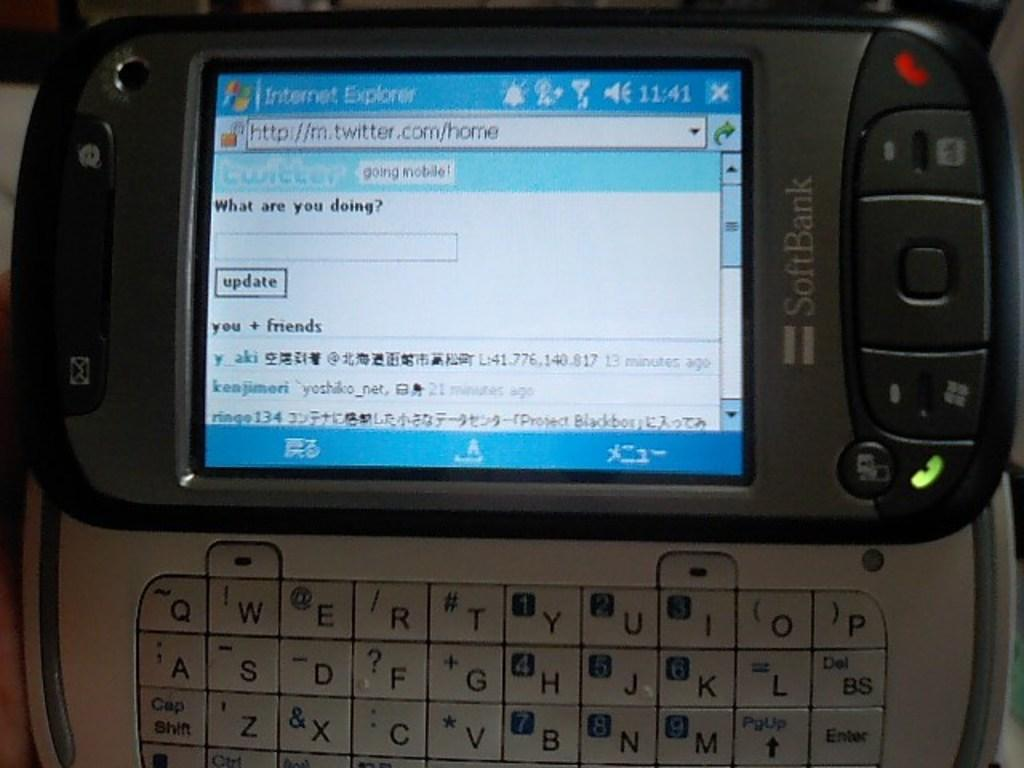<image>
Describe the image concisely. A messaging device with someone saying What are you doing. 